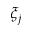<formula> <loc_0><loc_0><loc_500><loc_500>\xi _ { j }</formula> 